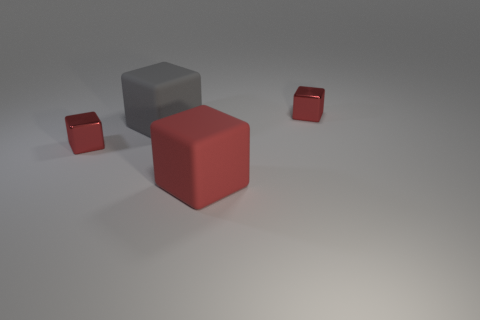How many objects are there in the image, and can you describe them? There are four objects in the image. Starting from the front, there's a large red matte cube, behind it a larger grey matte cube, and two smaller red matte cubes towards the right at varying distances from the large red cube. 